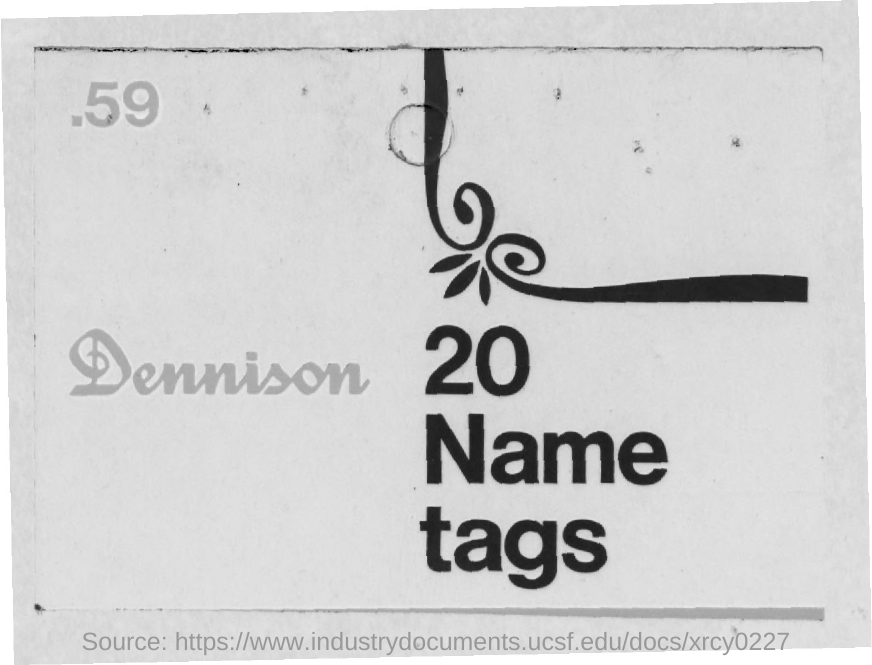Indicate a few pertinent items in this graphic. The number located in the left top corner of the page is 59. There are 20 instances of the word 'Name tag' mentioned in this text. 